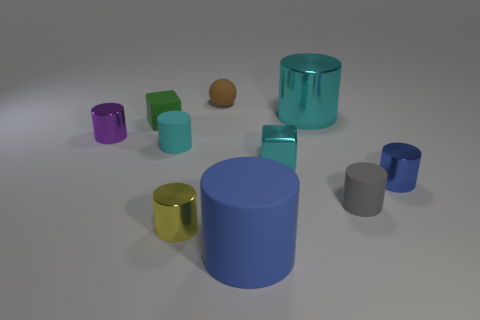There is a tiny metal cylinder that is on the right side of the cyan shiny cube; is its color the same as the large rubber object?
Make the answer very short. Yes. How big is the blue object that is to the left of the gray object?
Provide a short and direct response. Large. Is the large shiny cylinder the same color as the metallic cube?
Your response must be concise. Yes. Is there anything else that has the same shape as the brown matte thing?
Your answer should be very brief. No. What material is the object that is the same color as the big matte cylinder?
Your answer should be compact. Metal. Are there the same number of blue cylinders on the left side of the purple shiny cylinder and cyan cubes?
Your response must be concise. No. There is a gray cylinder; are there any small metallic things in front of it?
Give a very brief answer. Yes. Does the big matte object have the same shape as the cyan thing in front of the cyan rubber object?
Provide a short and direct response. No. There is a small ball that is made of the same material as the green thing; what is its color?
Provide a short and direct response. Brown. The small rubber sphere is what color?
Give a very brief answer. Brown. 